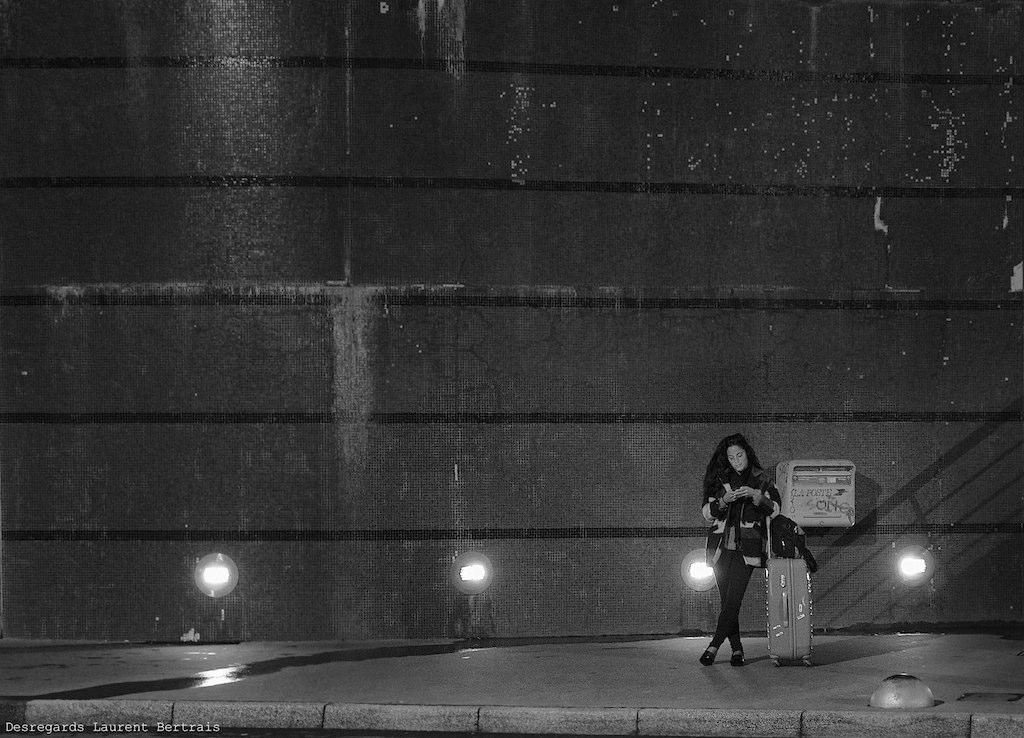What is the color scheme of the image? The image is black and white. Who is present in the image? There is a woman in the image. Where is the woman standing? The woman is standing on a footpath. What is the woman holding? The woman is holding some luggage. What can be seen behind the woman? There is a wall behind the woman. Can you see any animals from the zoo in the image? There is no zoo or any animals present in the image; it features a woman standing on a footpath with a wall behind her. 